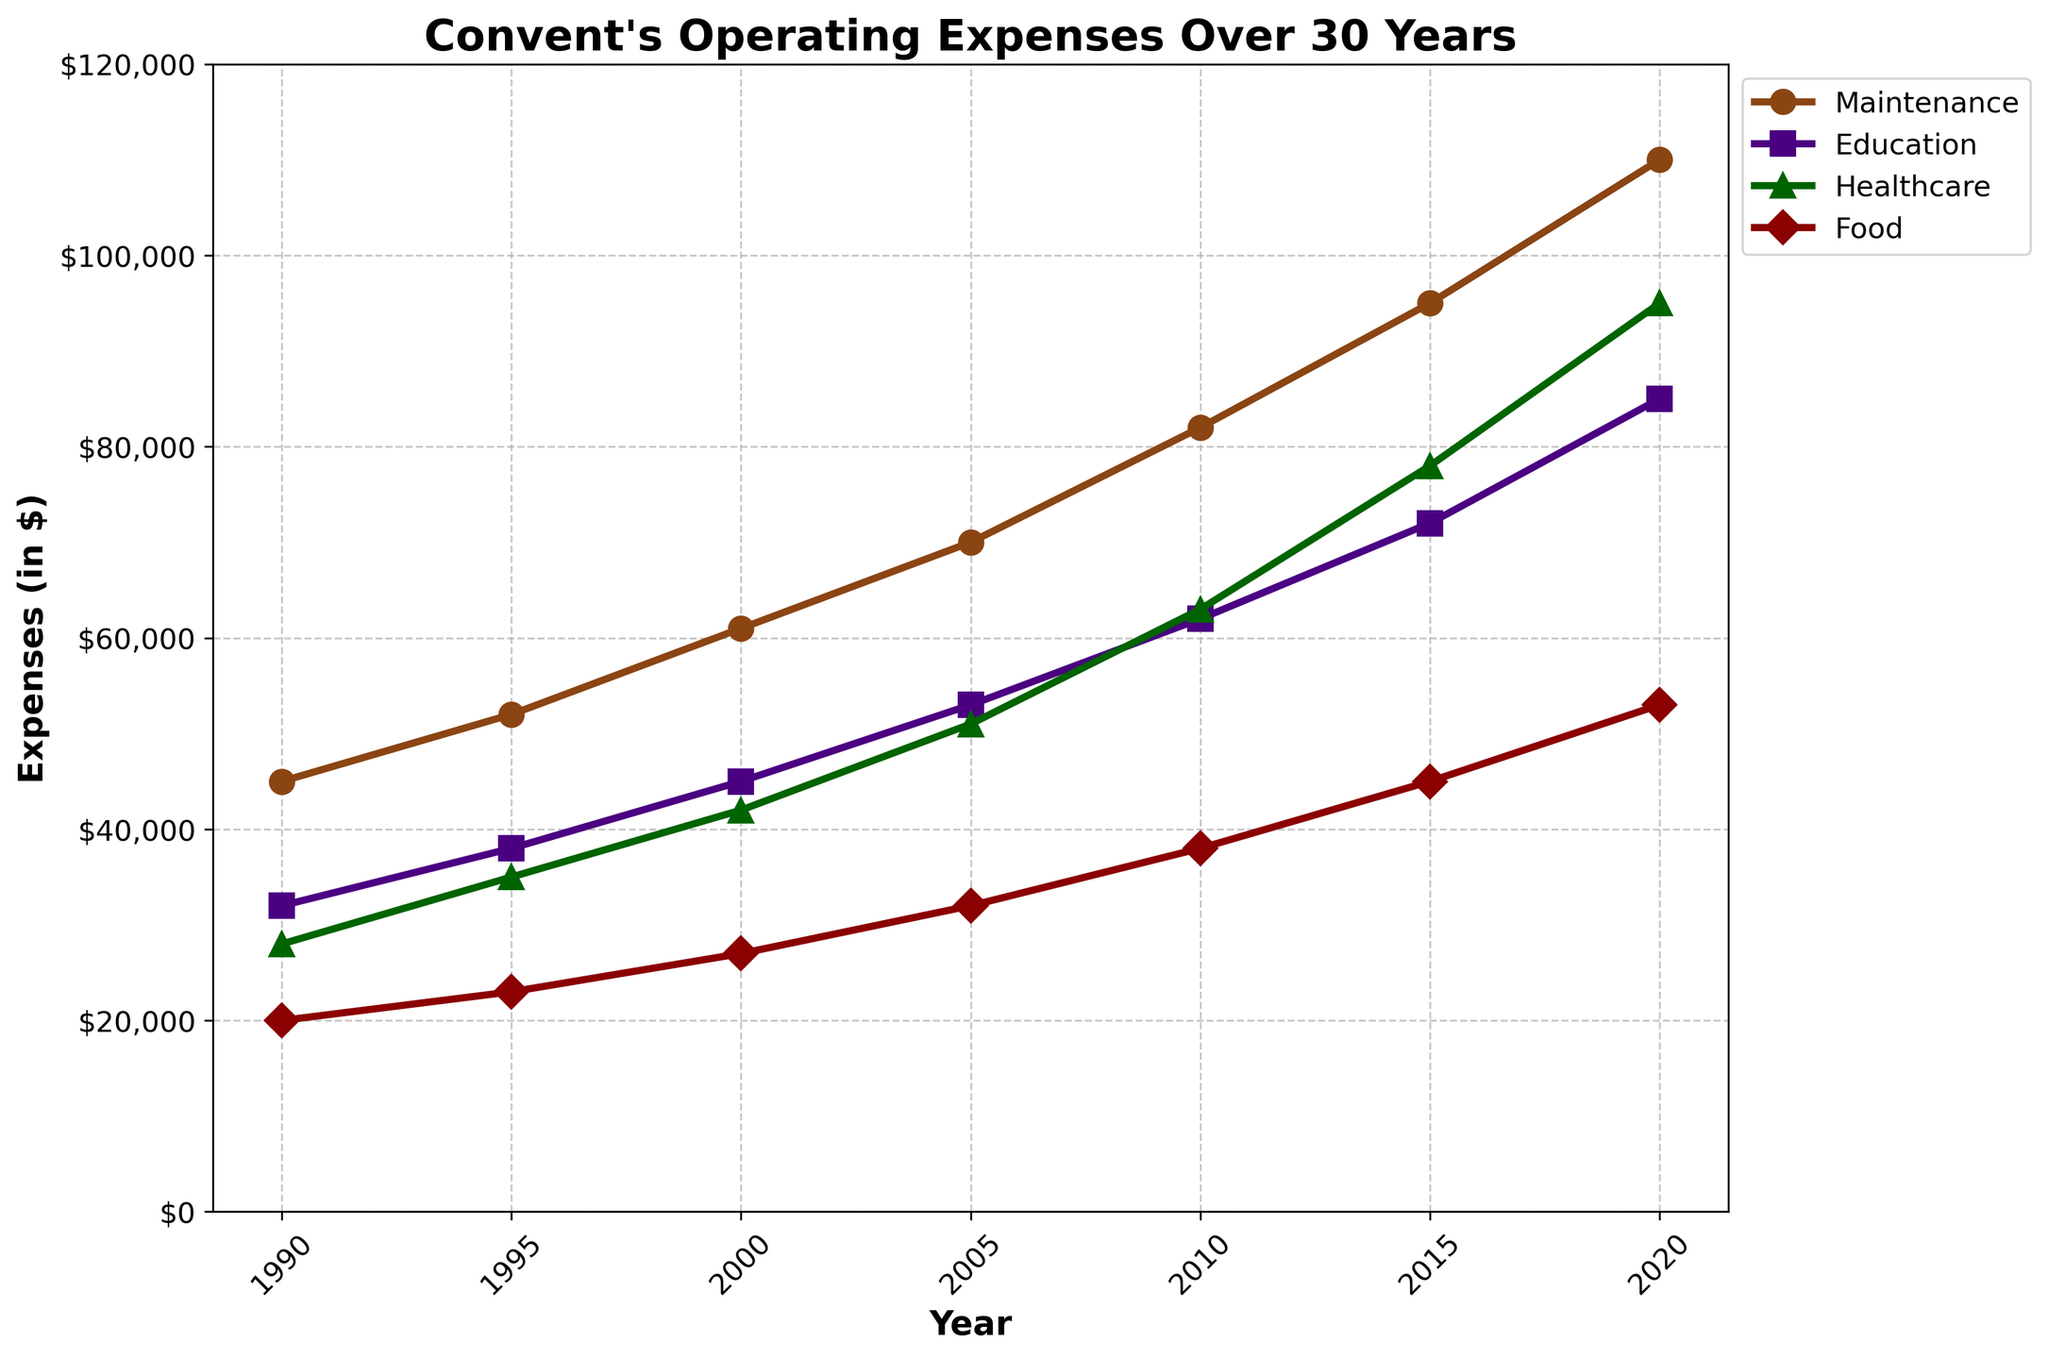Which expense category had the highest cost in 2020? In the year 2020, observe the line corresponding to each category and note their values. Maintenance is $110,000, Education is $85,000, Healthcare is $95,000, and Food is $53,000. Maintenance has the highest cost.
Answer: Maintenance How did the Food expenses change from 1990 to 2020? Observe the Food expenses at 1990 and 2020. In 1990, it was $20,000, and in 2020 it increased to $53,000. The change is $53,000 - $20,000, which is a $33,000 increase.
Answer: Increased by $33,000 Which category shows the most significant increase in expenses from 1990 to 2020? Calculate the differences for each category: Maintenance ($110,000 - $45,000 = $65,000), Education ($85,000 - $32,000 = $53,000), Healthcare ($95,000 - $28,000 = $67,000), and Food ($53,000 - $20,000 = $33,000). Healthcare shows the most significant increase.
Answer: Healthcare Between 2000 and 2010, which expense category experienced the highest growth rate? Compute the percentage increase for each category: Maintenance (($82,000 - $61,000) / $61,000) * 100 ≈ 34.4%, Education (($62,000 - $45,000) / $45,000) * 100 ≈ 37.8%, Healthcare (($63,000 - $42,000) / $42,000) * 100 ≈ 50%, Food (($38,000 - $27,000) / $27,000) * 100 ≈ 40.7%. Healthcare had the highest growth rate.
Answer: Healthcare What is the average expense for Education over the entire period? Sum the Education expenses for all years and divide by the number of years: ($32,000 + $38,000 + $45,000 + $53,000 + $62,000 + $72,000 + $85,000) / 7 ≈ $55,285.71.
Answer: $55,285.71 Which year witnessed the sharpest increase in Maintenance expenses compared to the previous period? Calculate the year-to-year increases: 1995 ($52,000 - $45,000 = $7,000), 2000 ($61,000 - $52,000 = $9,000), 2005 ($70,000 - $61,000 = $9,000), 2010 ($82,000 - $70,000 = $12,000), 2015 ($95,000 - $82,000 = $13,000), 2020 ($110,000 - $95,000 = $15,000). The sharpest increase occurred between 2015 and 2020 by $15,000.
Answer: 2020 In which year did Food expenses cross the $40,000 mark? Track the Food expense values over the years and find the first year it exceeds $40,000. This occurs in 2015 when Food expenses reached $45,000.
Answer: 2015 